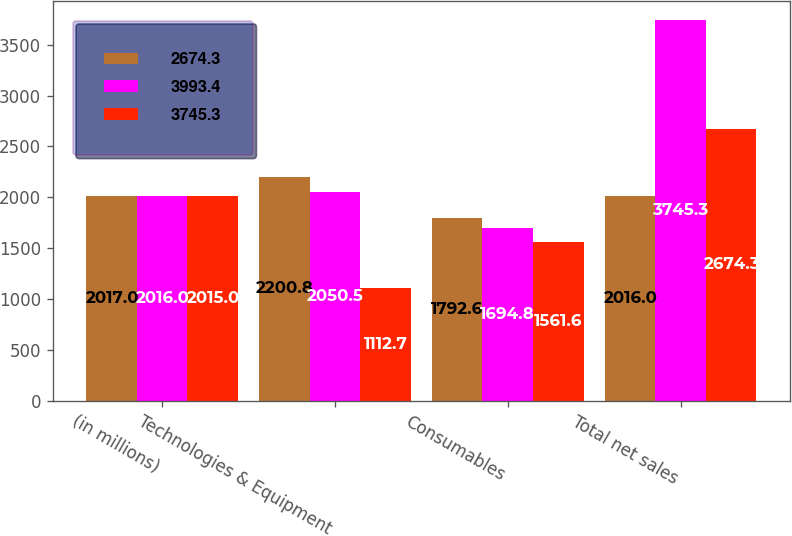<chart> <loc_0><loc_0><loc_500><loc_500><stacked_bar_chart><ecel><fcel>(in millions)<fcel>Technologies & Equipment<fcel>Consumables<fcel>Total net sales<nl><fcel>2674.3<fcel>2017<fcel>2200.8<fcel>1792.6<fcel>2016<nl><fcel>3993.4<fcel>2016<fcel>2050.5<fcel>1694.8<fcel>3745.3<nl><fcel>3745.3<fcel>2015<fcel>1112.7<fcel>1561.6<fcel>2674.3<nl></chart> 